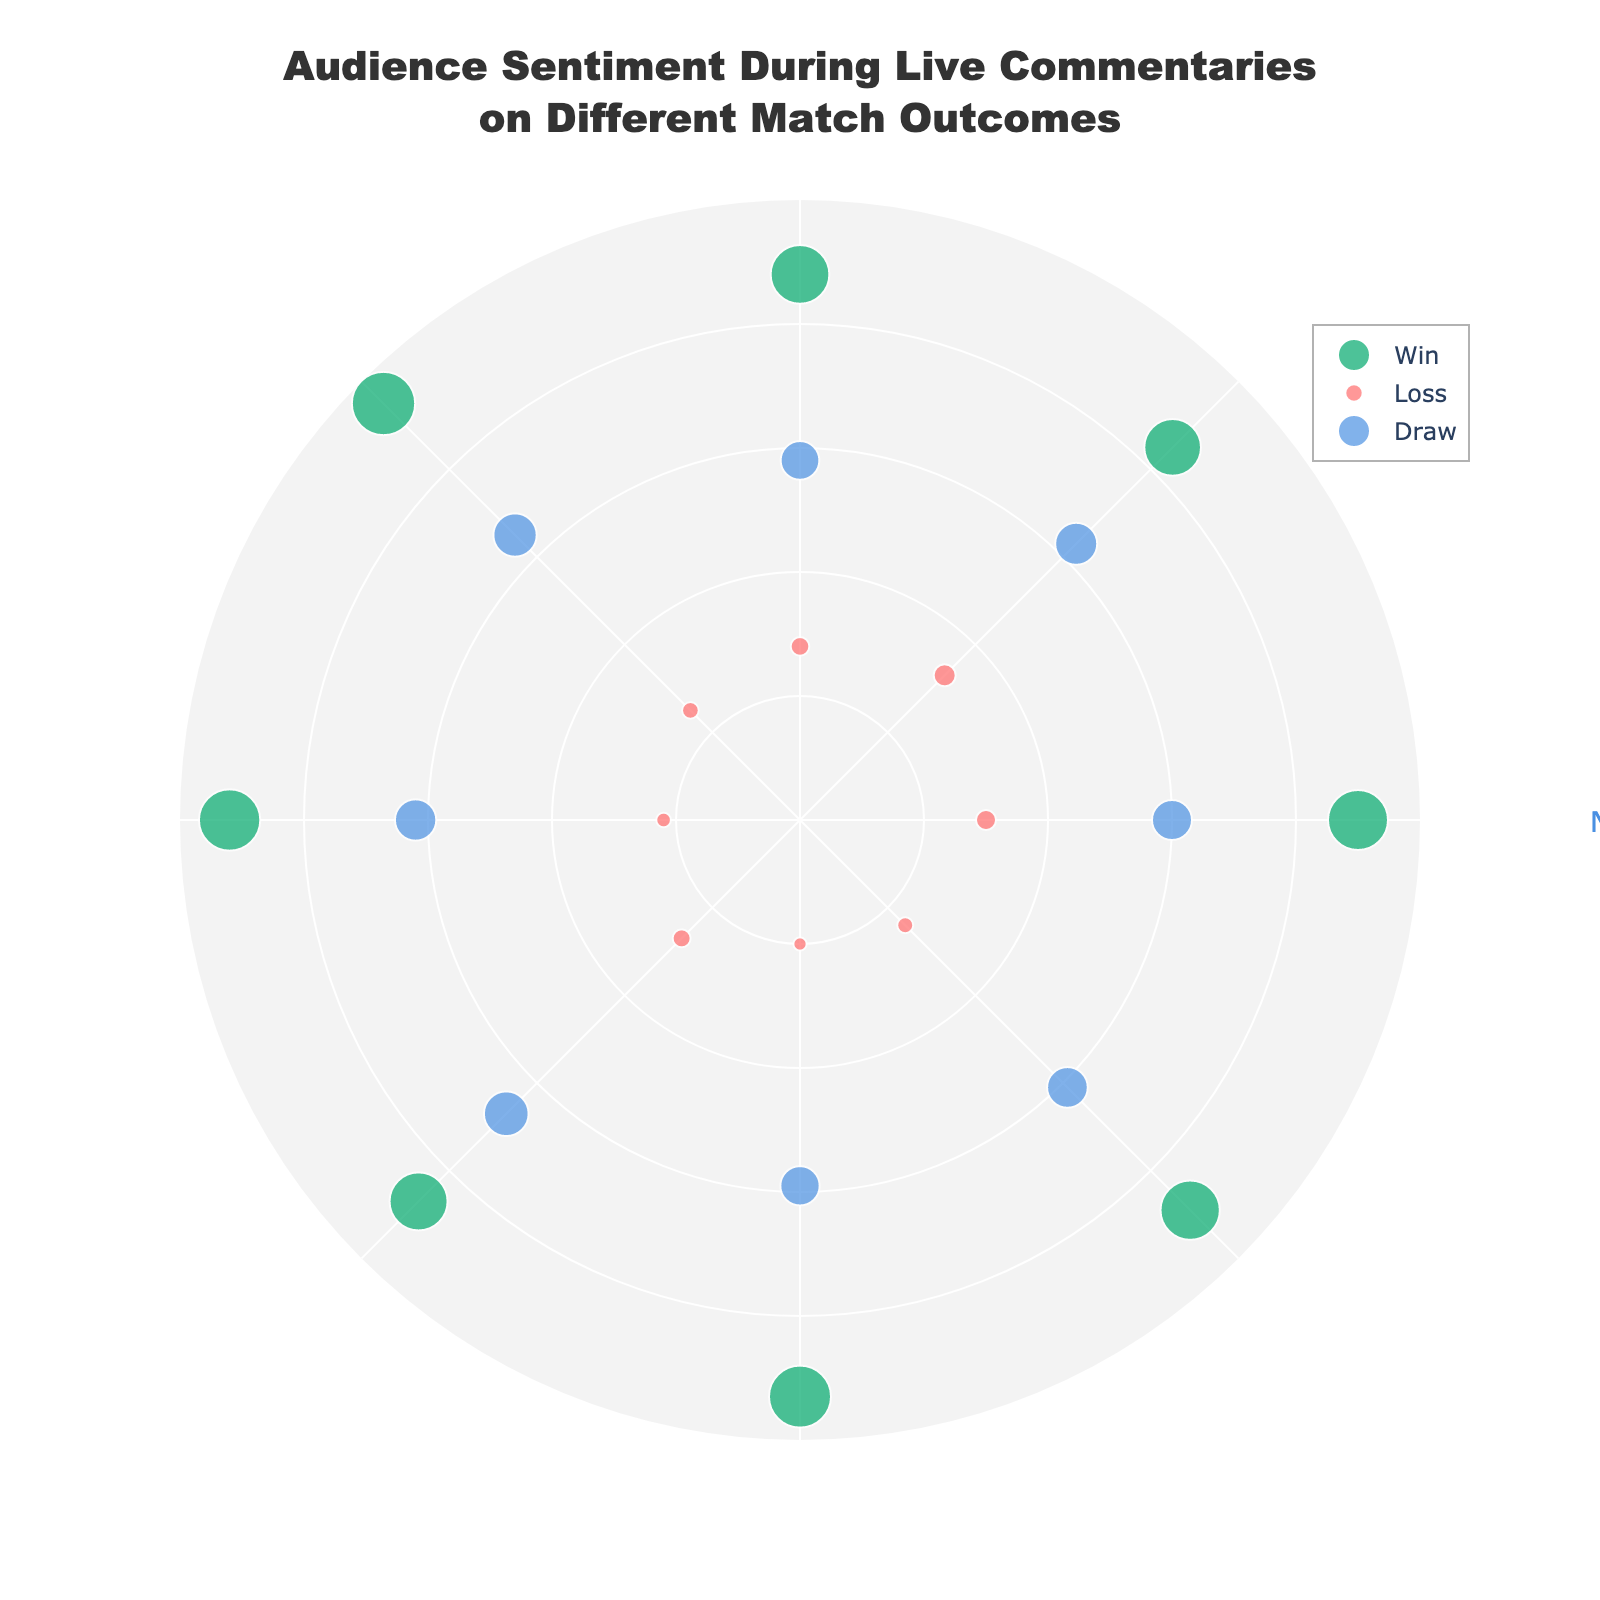What is the title of the chart? The title of the chart is displayed at the top of the figure. It reads "Audience Sentiment During Live Commentaries on Different Match Outcomes".
Answer: Audience Sentiment During Live Commentaries on Different Match Outcomes How many different categories are represented in the plot? By examining the legend, one can identify three categories represented in the chart: Win, Loss, and Draw.
Answer: Three What color represents the 'Win' category? The 'Win' category data points are represented by a specific color in the scatter plot. This color is green.
Answer: Green Which category has the highest radial value? The radial values for each category's data points (Win, Loss, Draw) need to be compared. The 'Win' category has data points with the highest radial values, peaking at 95.
Answer: Win What is the radial value of the 'Loss' category at 180 degrees? To find the radial value at the 180-degree angle for the 'Loss' category, look at the data point positioned at this angle. The value is 22.
Answer: 22 Are there any data points in the 'Negative' sentiment above a 40 radius? To answer this, observe the radial values for the 'Loss' (Negative sentiment) category. All values are below 40, indicating no points are above this radial value.
Answer: No What is the average radial value for the 'Draw' category? Calculate the average by summing the radial values of the 'Draw' category (60, 63, 58, 65, 62, 67, 59, 61) and dividing by the number of points. The average is (60 + 63 + 58 + 65 + 62 + 67 + 59 + 61) / 8 = 62.
Answer: 62 Compare the sentiment strength between 'Win' and 'Loss' categories. For sentiment strength, look at the radial values: 'Win' category has values like 90, 85, 88, etc., while 'Loss' has values like 30, 33, etc. 'Win' has higher radial values, indicating stronger sentiment.
Answer: Win has stronger sentiment What is the angular distribution pattern for the 'Draw' category? The 'Draw' category data points are evenly distributed every 45 degrees (0, 45, 90, 135, 180, 225, 270, 315), forming a balanced pattern around the circle.
Answer: Evenly distributed every 45 degrees How does the plot's background color enhance readability? The plot's background color is a light grey (rgba(240, 240, 240, 0.8)), which enhances contrast and readability of the data points and labels on the plot.
Answer: Enhances contrast and readability 